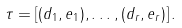<formula> <loc_0><loc_0><loc_500><loc_500>\tau = [ ( d _ { 1 } , e _ { 1 } ) , \dots , ( d _ { r } , e _ { r } ) ] \, .</formula> 